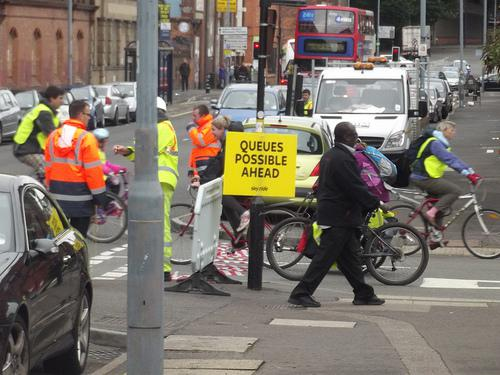Question: why are the traffic police wearing reflectors?
Choices:
A. To be easily identified.
B. Safety.
C. It's dark.
D. No other plausible answer.
Answer with the letter. Answer: A Question: what color is the sign besides the road?
Choices:
A. Red.
B. Yellow.
C. White.
D. Blue.
Answer with the letter. Answer: B Question: who are in the photo?
Choices:
A. Cars.
B. Shop owners.
C. Street vendors.
D. Pedestrians.
Answer with the letter. Answer: D Question: what are the pedestrians doing?
Choices:
A. Talking.
B. Singing.
C. Walking.
D. Skipping.
Answer with the letter. Answer: C Question: what else are in the street?
Choices:
A. People.
B. Parade floats.
C. Vehicles.
D. Road construction equipment.
Answer with the letter. Answer: C 